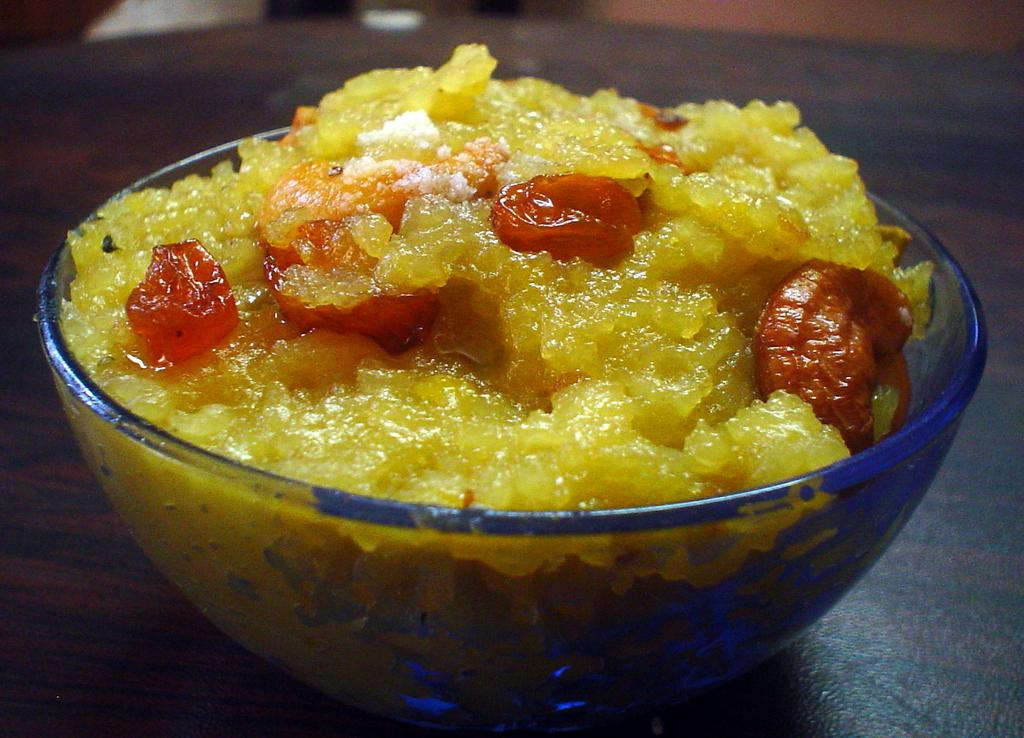What is on the table in the image? There is a glass bowl on the table in the image. What is inside the glass bowl? The glass bowl contains yellow-colored sweets and a red-colored jerry. What color is the jelly in the glass bowl? The jelly in the glass bowl is red. What can be seen in the top right of the image? There is a wall visible in the top right of the image. Can you see any waves crashing against the shore in the image? There are no waves or shore visible in the image; it features a glass bowl with sweets and a jelly on a table. Is there a tiger visible in the image? There is no tiger present in the image. 